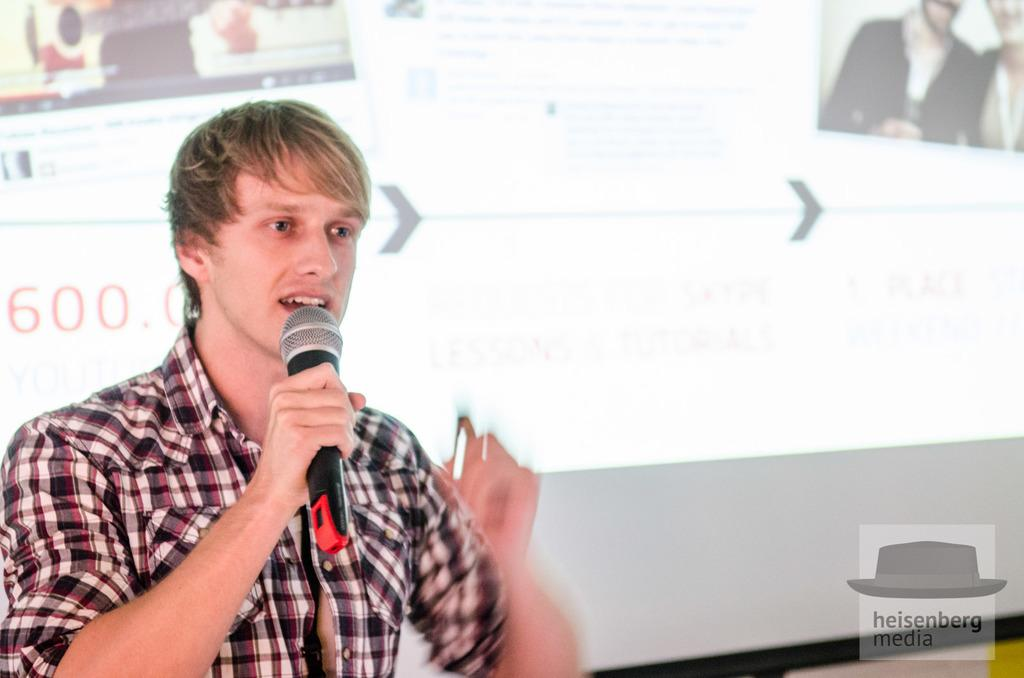Who is the main subject in the image? There is a man in the image. What is the man holding in his hand? The man is holding a mic with his hand. What is the man doing with the mic? The man is talking. What can be seen in the background of the image? There is a screen in the background of the image. What type of creature is standing on the man's feet in the image? There is no creature present in the image, and the man's feet are not visible. 